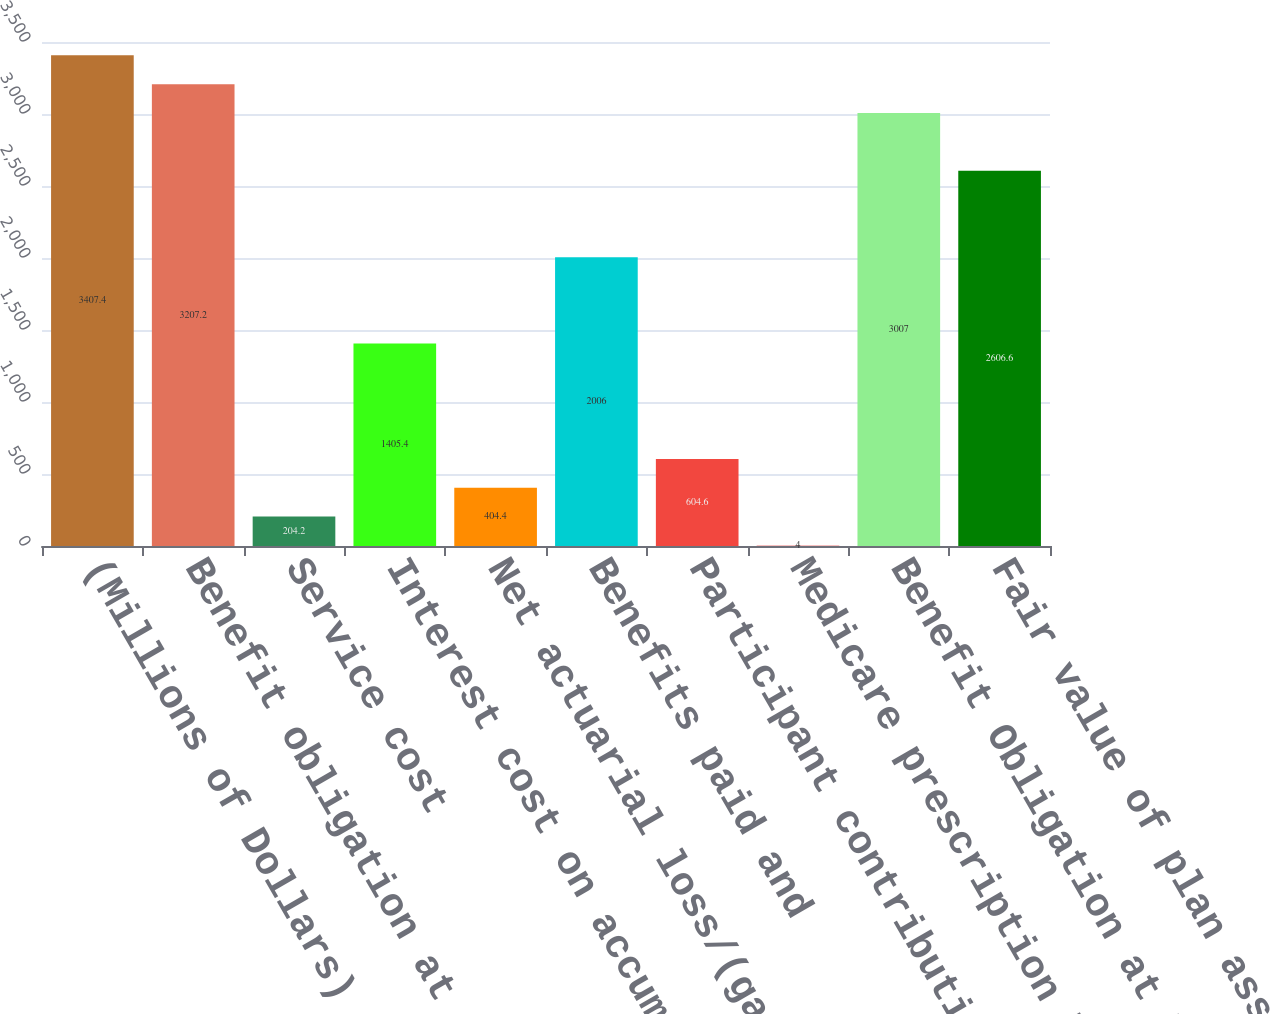<chart> <loc_0><loc_0><loc_500><loc_500><bar_chart><fcel>(Millions of Dollars)<fcel>Benefit obligation at<fcel>Service cost<fcel>Interest cost on accumulated<fcel>Net actuarial loss/(gain)<fcel>Benefits paid and<fcel>Participant contributions<fcel>Medicare prescription benefit<fcel>Benefit Obligation at End of<fcel>Fair value of plan assets at<nl><fcel>3407.4<fcel>3207.2<fcel>204.2<fcel>1405.4<fcel>404.4<fcel>2006<fcel>604.6<fcel>4<fcel>3007<fcel>2606.6<nl></chart> 